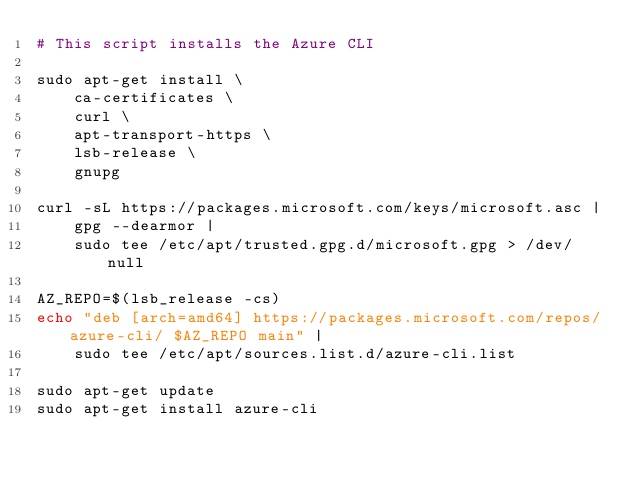Convert code to text. <code><loc_0><loc_0><loc_500><loc_500><_Bash_># This script installs the Azure CLI

sudo apt-get install \
    ca-certificates \
    curl \
    apt-transport-https \
    lsb-release \
    gnupg

curl -sL https://packages.microsoft.com/keys/microsoft.asc |
    gpg --dearmor |
    sudo tee /etc/apt/trusted.gpg.d/microsoft.gpg > /dev/null

AZ_REPO=$(lsb_release -cs)
echo "deb [arch=amd64] https://packages.microsoft.com/repos/azure-cli/ $AZ_REPO main" |
    sudo tee /etc/apt/sources.list.d/azure-cli.list

sudo apt-get update
sudo apt-get install azure-cli
</code> 